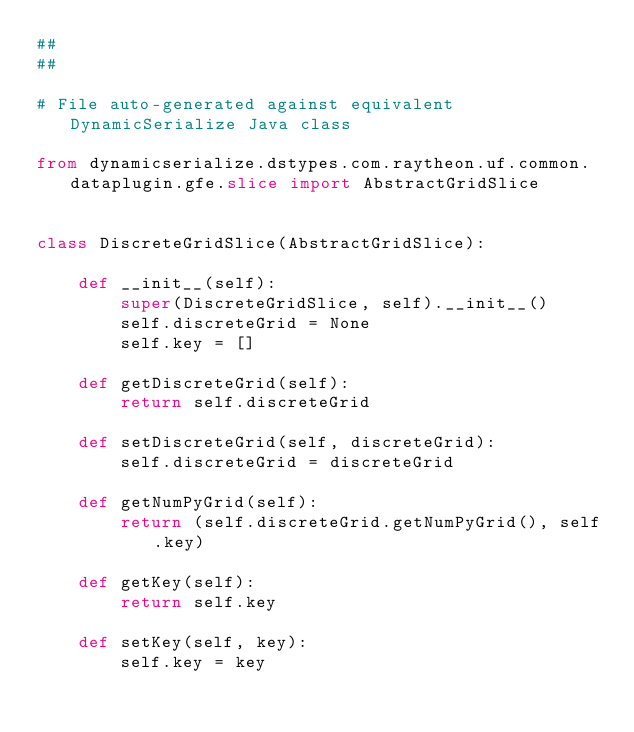<code> <loc_0><loc_0><loc_500><loc_500><_Python_>##
##

# File auto-generated against equivalent DynamicSerialize Java class

from dynamicserialize.dstypes.com.raytheon.uf.common.dataplugin.gfe.slice import AbstractGridSlice


class DiscreteGridSlice(AbstractGridSlice):

    def __init__(self):
        super(DiscreteGridSlice, self).__init__()
        self.discreteGrid = None
        self.key = []

    def getDiscreteGrid(self):
        return self.discreteGrid

    def setDiscreteGrid(self, discreteGrid):
        self.discreteGrid = discreteGrid

    def getNumPyGrid(self):
        return (self.discreteGrid.getNumPyGrid(), self.key)

    def getKey(self):
        return self.key

    def setKey(self, key):
        self.key = key
</code> 